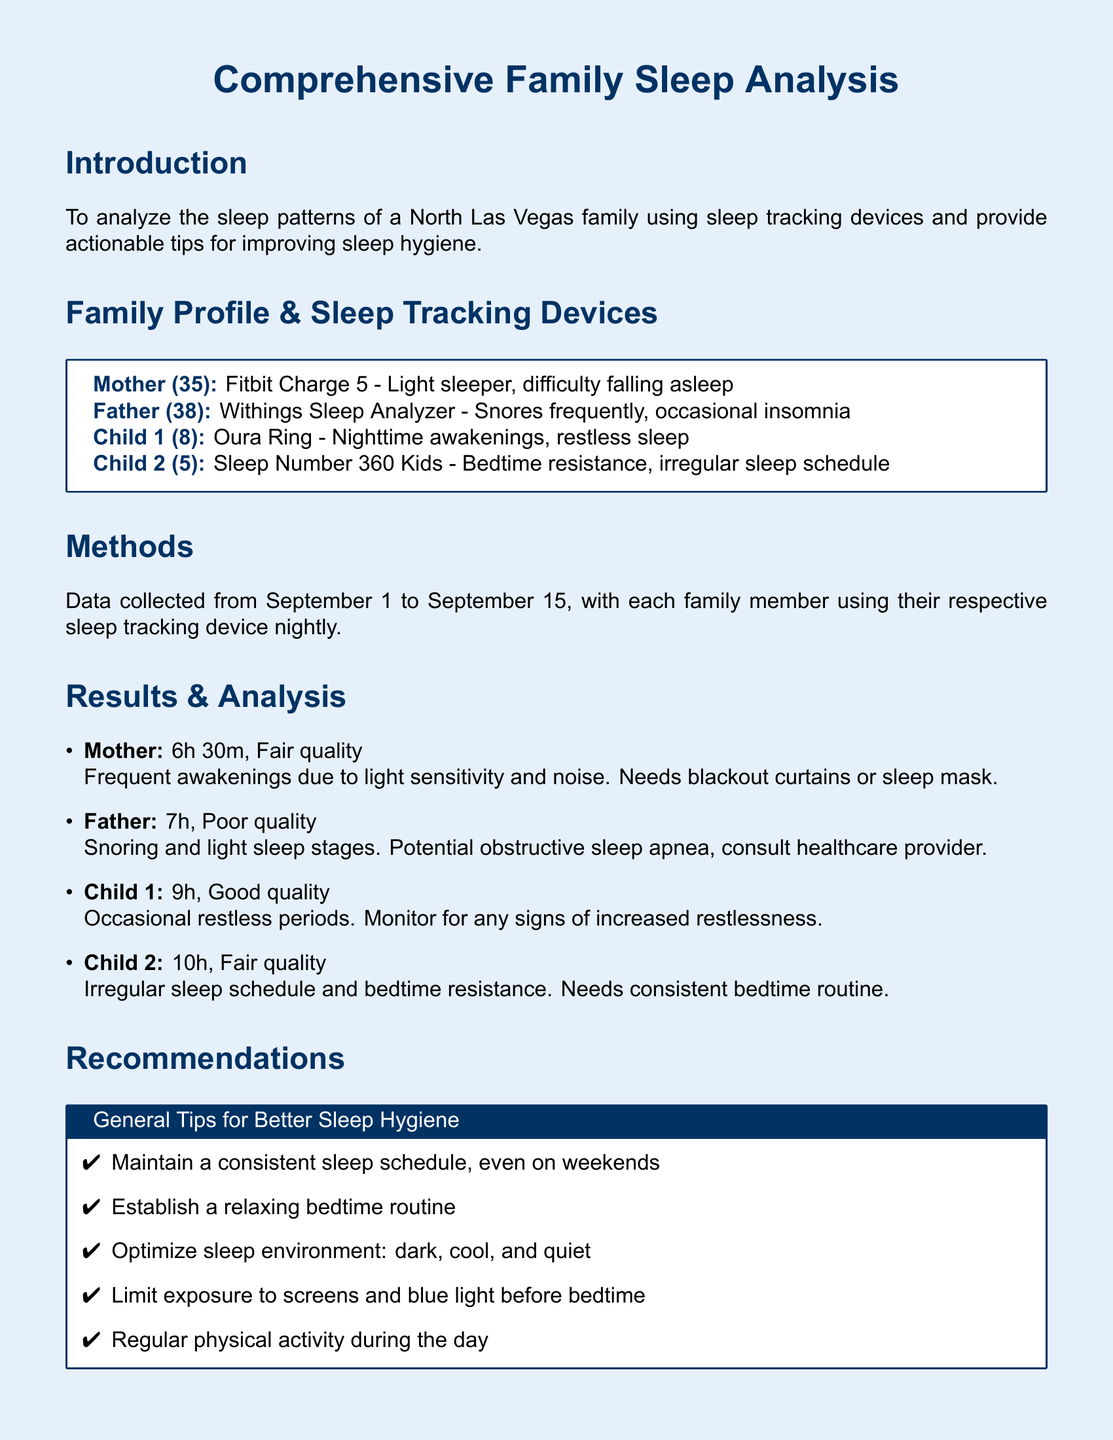What sleep tracker does the Mother use? The document specifies the sleep tracking device used by each family member, including the Mother.
Answer: Fitbit Charge 5 What is the average sleep duration of Child 2? The document lists the sleep data for each child including their sleep duration, specifically for Child 2.
Answer: 10h What issue does the Father experience during sleep? The results section mentions specific sleep issues faced by each family member, focusing on the Father's experience.
Answer: Snores frequently How many hours of sleep does the Mother get? The document provides specific sleep data for each family member, including the Mother’s total sleep time.
Answer: 6h 30m What is a specific tip for improving the Father’s sleep? In the recommendations section, specific sleep improvement tips are provided for each family member, including the Father.
Answer: Consult healthcare provider for snoring Which family member is described as a light sleeper? The document identifies each family member's sleep characteristics, highlighting the Mother as a light sleeper.
Answer: Mother What should the Child 2 avoid before bed? The recommendations include advice tailored for each family member, focusing on the Child 2’s bedtime habits.
Answer: Caffeine/sugar What sleep quality did Child 1 experience? The results section includes assessments of sleep quality for each family member, specifically noting Child 1's sleep experience.
Answer: Good quality 